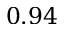<formula> <loc_0><loc_0><loc_500><loc_500>0 . 9 4</formula> 